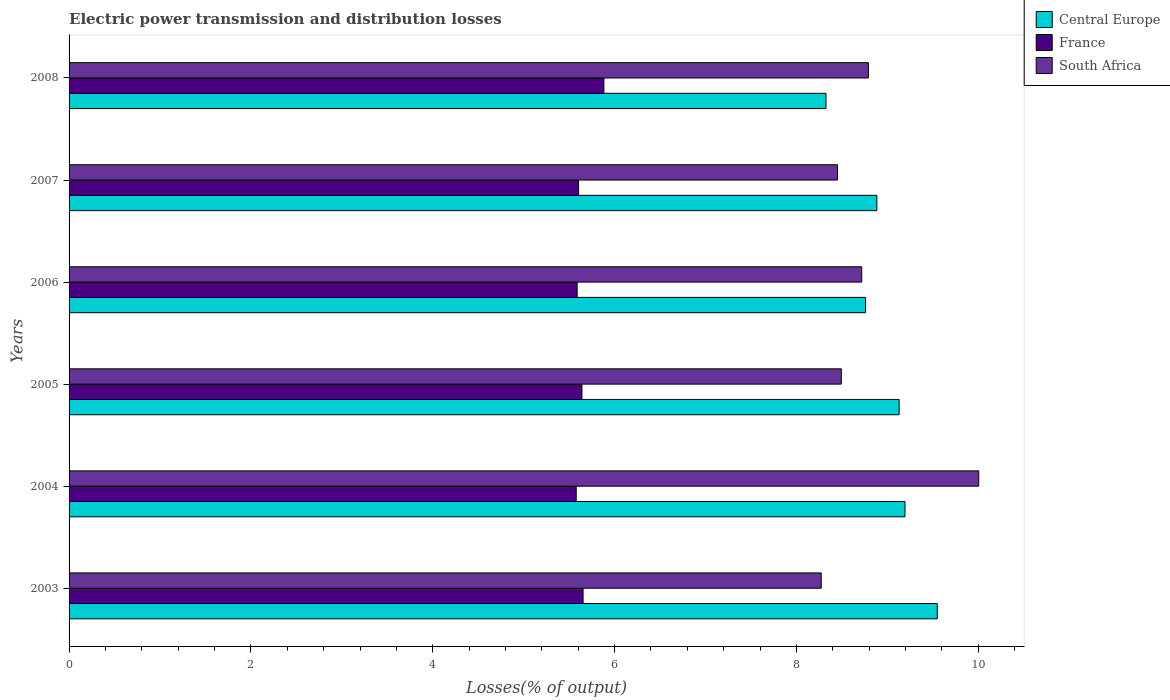Are the number of bars on each tick of the Y-axis equal?
Ensure brevity in your answer.  Yes. How many bars are there on the 2nd tick from the top?
Your answer should be very brief. 3. In how many cases, is the number of bars for a given year not equal to the number of legend labels?
Give a very brief answer. 0. What is the electric power transmission and distribution losses in Central Europe in 2004?
Keep it short and to the point. 9.19. Across all years, what is the maximum electric power transmission and distribution losses in France?
Provide a short and direct response. 5.88. Across all years, what is the minimum electric power transmission and distribution losses in France?
Your response must be concise. 5.58. In which year was the electric power transmission and distribution losses in Central Europe minimum?
Your answer should be very brief. 2008. What is the total electric power transmission and distribution losses in France in the graph?
Your answer should be compact. 33.95. What is the difference between the electric power transmission and distribution losses in France in 2007 and that in 2008?
Make the answer very short. -0.28. What is the difference between the electric power transmission and distribution losses in Central Europe in 2006 and the electric power transmission and distribution losses in France in 2007?
Give a very brief answer. 3.16. What is the average electric power transmission and distribution losses in France per year?
Offer a very short reply. 5.66. In the year 2004, what is the difference between the electric power transmission and distribution losses in France and electric power transmission and distribution losses in Central Europe?
Your response must be concise. -3.62. In how many years, is the electric power transmission and distribution losses in Central Europe greater than 7.2 %?
Provide a short and direct response. 6. What is the ratio of the electric power transmission and distribution losses in South Africa in 2004 to that in 2006?
Make the answer very short. 1.15. Is the difference between the electric power transmission and distribution losses in France in 2003 and 2005 greater than the difference between the electric power transmission and distribution losses in Central Europe in 2003 and 2005?
Your answer should be compact. No. What is the difference between the highest and the second highest electric power transmission and distribution losses in France?
Ensure brevity in your answer.  0.23. What is the difference between the highest and the lowest electric power transmission and distribution losses in Central Europe?
Give a very brief answer. 1.22. In how many years, is the electric power transmission and distribution losses in Central Europe greater than the average electric power transmission and distribution losses in Central Europe taken over all years?
Make the answer very short. 3. What does the 3rd bar from the top in 2004 represents?
Ensure brevity in your answer.  Central Europe. What does the 2nd bar from the bottom in 2007 represents?
Your response must be concise. France. Is it the case that in every year, the sum of the electric power transmission and distribution losses in France and electric power transmission and distribution losses in Central Europe is greater than the electric power transmission and distribution losses in South Africa?
Keep it short and to the point. Yes. How many bars are there?
Your answer should be compact. 18. Are all the bars in the graph horizontal?
Make the answer very short. Yes. How many years are there in the graph?
Ensure brevity in your answer.  6. What is the difference between two consecutive major ticks on the X-axis?
Give a very brief answer. 2. How are the legend labels stacked?
Your answer should be compact. Vertical. What is the title of the graph?
Provide a short and direct response. Electric power transmission and distribution losses. What is the label or title of the X-axis?
Provide a succinct answer. Losses(% of output). What is the label or title of the Y-axis?
Your response must be concise. Years. What is the Losses(% of output) in Central Europe in 2003?
Provide a succinct answer. 9.55. What is the Losses(% of output) in France in 2003?
Provide a short and direct response. 5.65. What is the Losses(% of output) in South Africa in 2003?
Offer a very short reply. 8.27. What is the Losses(% of output) in Central Europe in 2004?
Provide a succinct answer. 9.19. What is the Losses(% of output) of France in 2004?
Your answer should be very brief. 5.58. What is the Losses(% of output) of South Africa in 2004?
Give a very brief answer. 10. What is the Losses(% of output) in Central Europe in 2005?
Ensure brevity in your answer.  9.13. What is the Losses(% of output) of France in 2005?
Keep it short and to the point. 5.64. What is the Losses(% of output) in South Africa in 2005?
Ensure brevity in your answer.  8.49. What is the Losses(% of output) of Central Europe in 2006?
Make the answer very short. 8.76. What is the Losses(% of output) of France in 2006?
Keep it short and to the point. 5.59. What is the Losses(% of output) of South Africa in 2006?
Keep it short and to the point. 8.72. What is the Losses(% of output) of Central Europe in 2007?
Your response must be concise. 8.88. What is the Losses(% of output) in France in 2007?
Your answer should be very brief. 5.6. What is the Losses(% of output) of South Africa in 2007?
Provide a short and direct response. 8.45. What is the Losses(% of output) in Central Europe in 2008?
Make the answer very short. 8.33. What is the Losses(% of output) of France in 2008?
Give a very brief answer. 5.88. What is the Losses(% of output) of South Africa in 2008?
Your answer should be compact. 8.79. Across all years, what is the maximum Losses(% of output) in Central Europe?
Provide a short and direct response. 9.55. Across all years, what is the maximum Losses(% of output) in France?
Offer a very short reply. 5.88. Across all years, what is the maximum Losses(% of output) of South Africa?
Give a very brief answer. 10. Across all years, what is the minimum Losses(% of output) in Central Europe?
Your answer should be compact. 8.33. Across all years, what is the minimum Losses(% of output) of France?
Offer a terse response. 5.58. Across all years, what is the minimum Losses(% of output) in South Africa?
Provide a short and direct response. 8.27. What is the total Losses(% of output) in Central Europe in the graph?
Keep it short and to the point. 53.84. What is the total Losses(% of output) of France in the graph?
Provide a short and direct response. 33.95. What is the total Losses(% of output) in South Africa in the graph?
Offer a very short reply. 52.73. What is the difference between the Losses(% of output) in Central Europe in 2003 and that in 2004?
Keep it short and to the point. 0.36. What is the difference between the Losses(% of output) in France in 2003 and that in 2004?
Your answer should be compact. 0.08. What is the difference between the Losses(% of output) of South Africa in 2003 and that in 2004?
Offer a very short reply. -1.73. What is the difference between the Losses(% of output) in Central Europe in 2003 and that in 2005?
Provide a succinct answer. 0.42. What is the difference between the Losses(% of output) in France in 2003 and that in 2005?
Provide a succinct answer. 0.01. What is the difference between the Losses(% of output) in South Africa in 2003 and that in 2005?
Ensure brevity in your answer.  -0.22. What is the difference between the Losses(% of output) of Central Europe in 2003 and that in 2006?
Your answer should be compact. 0.79. What is the difference between the Losses(% of output) of France in 2003 and that in 2006?
Your answer should be very brief. 0.07. What is the difference between the Losses(% of output) of South Africa in 2003 and that in 2006?
Ensure brevity in your answer.  -0.45. What is the difference between the Losses(% of output) of Central Europe in 2003 and that in 2007?
Provide a succinct answer. 0.66. What is the difference between the Losses(% of output) of France in 2003 and that in 2007?
Provide a succinct answer. 0.05. What is the difference between the Losses(% of output) of South Africa in 2003 and that in 2007?
Provide a short and direct response. -0.18. What is the difference between the Losses(% of output) in Central Europe in 2003 and that in 2008?
Ensure brevity in your answer.  1.22. What is the difference between the Losses(% of output) of France in 2003 and that in 2008?
Offer a terse response. -0.23. What is the difference between the Losses(% of output) in South Africa in 2003 and that in 2008?
Offer a very short reply. -0.52. What is the difference between the Losses(% of output) of Central Europe in 2004 and that in 2005?
Keep it short and to the point. 0.06. What is the difference between the Losses(% of output) in France in 2004 and that in 2005?
Ensure brevity in your answer.  -0.06. What is the difference between the Losses(% of output) in South Africa in 2004 and that in 2005?
Offer a very short reply. 1.51. What is the difference between the Losses(% of output) of Central Europe in 2004 and that in 2006?
Keep it short and to the point. 0.43. What is the difference between the Losses(% of output) in France in 2004 and that in 2006?
Give a very brief answer. -0.01. What is the difference between the Losses(% of output) of South Africa in 2004 and that in 2006?
Your answer should be very brief. 1.29. What is the difference between the Losses(% of output) in Central Europe in 2004 and that in 2007?
Provide a short and direct response. 0.31. What is the difference between the Losses(% of output) in France in 2004 and that in 2007?
Keep it short and to the point. -0.03. What is the difference between the Losses(% of output) of South Africa in 2004 and that in 2007?
Offer a terse response. 1.55. What is the difference between the Losses(% of output) of Central Europe in 2004 and that in 2008?
Give a very brief answer. 0.87. What is the difference between the Losses(% of output) in France in 2004 and that in 2008?
Ensure brevity in your answer.  -0.3. What is the difference between the Losses(% of output) of South Africa in 2004 and that in 2008?
Ensure brevity in your answer.  1.21. What is the difference between the Losses(% of output) in Central Europe in 2005 and that in 2006?
Offer a terse response. 0.37. What is the difference between the Losses(% of output) of France in 2005 and that in 2006?
Offer a terse response. 0.05. What is the difference between the Losses(% of output) in South Africa in 2005 and that in 2006?
Your answer should be very brief. -0.22. What is the difference between the Losses(% of output) of Central Europe in 2005 and that in 2007?
Provide a succinct answer. 0.24. What is the difference between the Losses(% of output) of France in 2005 and that in 2007?
Provide a succinct answer. 0.04. What is the difference between the Losses(% of output) of South Africa in 2005 and that in 2007?
Provide a short and direct response. 0.04. What is the difference between the Losses(% of output) of Central Europe in 2005 and that in 2008?
Your answer should be compact. 0.8. What is the difference between the Losses(% of output) in France in 2005 and that in 2008?
Your answer should be very brief. -0.24. What is the difference between the Losses(% of output) in South Africa in 2005 and that in 2008?
Provide a short and direct response. -0.3. What is the difference between the Losses(% of output) of Central Europe in 2006 and that in 2007?
Your answer should be very brief. -0.12. What is the difference between the Losses(% of output) of France in 2006 and that in 2007?
Give a very brief answer. -0.02. What is the difference between the Losses(% of output) of South Africa in 2006 and that in 2007?
Make the answer very short. 0.27. What is the difference between the Losses(% of output) in Central Europe in 2006 and that in 2008?
Offer a very short reply. 0.43. What is the difference between the Losses(% of output) in France in 2006 and that in 2008?
Offer a terse response. -0.29. What is the difference between the Losses(% of output) of South Africa in 2006 and that in 2008?
Offer a terse response. -0.07. What is the difference between the Losses(% of output) of Central Europe in 2007 and that in 2008?
Provide a short and direct response. 0.56. What is the difference between the Losses(% of output) in France in 2007 and that in 2008?
Provide a short and direct response. -0.28. What is the difference between the Losses(% of output) in South Africa in 2007 and that in 2008?
Your answer should be very brief. -0.34. What is the difference between the Losses(% of output) in Central Europe in 2003 and the Losses(% of output) in France in 2004?
Offer a very short reply. 3.97. What is the difference between the Losses(% of output) in Central Europe in 2003 and the Losses(% of output) in South Africa in 2004?
Keep it short and to the point. -0.46. What is the difference between the Losses(% of output) of France in 2003 and the Losses(% of output) of South Africa in 2004?
Your response must be concise. -4.35. What is the difference between the Losses(% of output) in Central Europe in 2003 and the Losses(% of output) in France in 2005?
Keep it short and to the point. 3.91. What is the difference between the Losses(% of output) of Central Europe in 2003 and the Losses(% of output) of South Africa in 2005?
Offer a terse response. 1.06. What is the difference between the Losses(% of output) of France in 2003 and the Losses(% of output) of South Africa in 2005?
Provide a short and direct response. -2.84. What is the difference between the Losses(% of output) in Central Europe in 2003 and the Losses(% of output) in France in 2006?
Provide a short and direct response. 3.96. What is the difference between the Losses(% of output) in Central Europe in 2003 and the Losses(% of output) in South Africa in 2006?
Ensure brevity in your answer.  0.83. What is the difference between the Losses(% of output) in France in 2003 and the Losses(% of output) in South Africa in 2006?
Make the answer very short. -3.06. What is the difference between the Losses(% of output) in Central Europe in 2003 and the Losses(% of output) in France in 2007?
Your answer should be very brief. 3.95. What is the difference between the Losses(% of output) in Central Europe in 2003 and the Losses(% of output) in South Africa in 2007?
Your response must be concise. 1.1. What is the difference between the Losses(% of output) in France in 2003 and the Losses(% of output) in South Africa in 2007?
Your answer should be very brief. -2.8. What is the difference between the Losses(% of output) of Central Europe in 2003 and the Losses(% of output) of France in 2008?
Your response must be concise. 3.67. What is the difference between the Losses(% of output) in Central Europe in 2003 and the Losses(% of output) in South Africa in 2008?
Offer a very short reply. 0.76. What is the difference between the Losses(% of output) of France in 2003 and the Losses(% of output) of South Africa in 2008?
Give a very brief answer. -3.14. What is the difference between the Losses(% of output) of Central Europe in 2004 and the Losses(% of output) of France in 2005?
Your answer should be compact. 3.55. What is the difference between the Losses(% of output) in Central Europe in 2004 and the Losses(% of output) in South Africa in 2005?
Offer a very short reply. 0.7. What is the difference between the Losses(% of output) of France in 2004 and the Losses(% of output) of South Africa in 2005?
Offer a very short reply. -2.92. What is the difference between the Losses(% of output) in Central Europe in 2004 and the Losses(% of output) in France in 2006?
Your answer should be compact. 3.61. What is the difference between the Losses(% of output) of Central Europe in 2004 and the Losses(% of output) of South Africa in 2006?
Keep it short and to the point. 0.48. What is the difference between the Losses(% of output) of France in 2004 and the Losses(% of output) of South Africa in 2006?
Your answer should be very brief. -3.14. What is the difference between the Losses(% of output) in Central Europe in 2004 and the Losses(% of output) in France in 2007?
Give a very brief answer. 3.59. What is the difference between the Losses(% of output) of Central Europe in 2004 and the Losses(% of output) of South Africa in 2007?
Your answer should be very brief. 0.74. What is the difference between the Losses(% of output) of France in 2004 and the Losses(% of output) of South Africa in 2007?
Offer a terse response. -2.87. What is the difference between the Losses(% of output) of Central Europe in 2004 and the Losses(% of output) of France in 2008?
Your response must be concise. 3.31. What is the difference between the Losses(% of output) in Central Europe in 2004 and the Losses(% of output) in South Africa in 2008?
Give a very brief answer. 0.4. What is the difference between the Losses(% of output) of France in 2004 and the Losses(% of output) of South Africa in 2008?
Your answer should be compact. -3.21. What is the difference between the Losses(% of output) of Central Europe in 2005 and the Losses(% of output) of France in 2006?
Your response must be concise. 3.54. What is the difference between the Losses(% of output) of Central Europe in 2005 and the Losses(% of output) of South Africa in 2006?
Provide a short and direct response. 0.41. What is the difference between the Losses(% of output) of France in 2005 and the Losses(% of output) of South Africa in 2006?
Make the answer very short. -3.08. What is the difference between the Losses(% of output) in Central Europe in 2005 and the Losses(% of output) in France in 2007?
Provide a short and direct response. 3.53. What is the difference between the Losses(% of output) of Central Europe in 2005 and the Losses(% of output) of South Africa in 2007?
Make the answer very short. 0.68. What is the difference between the Losses(% of output) in France in 2005 and the Losses(% of output) in South Africa in 2007?
Provide a succinct answer. -2.81. What is the difference between the Losses(% of output) in Central Europe in 2005 and the Losses(% of output) in France in 2008?
Your answer should be compact. 3.25. What is the difference between the Losses(% of output) of Central Europe in 2005 and the Losses(% of output) of South Africa in 2008?
Make the answer very short. 0.34. What is the difference between the Losses(% of output) of France in 2005 and the Losses(% of output) of South Africa in 2008?
Your answer should be compact. -3.15. What is the difference between the Losses(% of output) of Central Europe in 2006 and the Losses(% of output) of France in 2007?
Your answer should be very brief. 3.16. What is the difference between the Losses(% of output) in Central Europe in 2006 and the Losses(% of output) in South Africa in 2007?
Provide a succinct answer. 0.31. What is the difference between the Losses(% of output) in France in 2006 and the Losses(% of output) in South Africa in 2007?
Offer a very short reply. -2.86. What is the difference between the Losses(% of output) of Central Europe in 2006 and the Losses(% of output) of France in 2008?
Make the answer very short. 2.88. What is the difference between the Losses(% of output) of Central Europe in 2006 and the Losses(% of output) of South Africa in 2008?
Offer a terse response. -0.03. What is the difference between the Losses(% of output) in France in 2006 and the Losses(% of output) in South Africa in 2008?
Keep it short and to the point. -3.2. What is the difference between the Losses(% of output) in Central Europe in 2007 and the Losses(% of output) in France in 2008?
Keep it short and to the point. 3. What is the difference between the Losses(% of output) of Central Europe in 2007 and the Losses(% of output) of South Africa in 2008?
Your answer should be very brief. 0.09. What is the difference between the Losses(% of output) in France in 2007 and the Losses(% of output) in South Africa in 2008?
Ensure brevity in your answer.  -3.19. What is the average Losses(% of output) in Central Europe per year?
Your answer should be compact. 8.97. What is the average Losses(% of output) in France per year?
Make the answer very short. 5.66. What is the average Losses(% of output) of South Africa per year?
Make the answer very short. 8.79. In the year 2003, what is the difference between the Losses(% of output) of Central Europe and Losses(% of output) of France?
Keep it short and to the point. 3.9. In the year 2003, what is the difference between the Losses(% of output) of Central Europe and Losses(% of output) of South Africa?
Offer a very short reply. 1.28. In the year 2003, what is the difference between the Losses(% of output) in France and Losses(% of output) in South Africa?
Your response must be concise. -2.62. In the year 2004, what is the difference between the Losses(% of output) of Central Europe and Losses(% of output) of France?
Your answer should be very brief. 3.62. In the year 2004, what is the difference between the Losses(% of output) in Central Europe and Losses(% of output) in South Africa?
Provide a succinct answer. -0.81. In the year 2004, what is the difference between the Losses(% of output) in France and Losses(% of output) in South Africa?
Provide a short and direct response. -4.43. In the year 2005, what is the difference between the Losses(% of output) of Central Europe and Losses(% of output) of France?
Offer a very short reply. 3.49. In the year 2005, what is the difference between the Losses(% of output) of Central Europe and Losses(% of output) of South Africa?
Keep it short and to the point. 0.64. In the year 2005, what is the difference between the Losses(% of output) of France and Losses(% of output) of South Africa?
Offer a very short reply. -2.85. In the year 2006, what is the difference between the Losses(% of output) of Central Europe and Losses(% of output) of France?
Your answer should be very brief. 3.17. In the year 2006, what is the difference between the Losses(% of output) in Central Europe and Losses(% of output) in South Africa?
Your response must be concise. 0.04. In the year 2006, what is the difference between the Losses(% of output) of France and Losses(% of output) of South Africa?
Your answer should be very brief. -3.13. In the year 2007, what is the difference between the Losses(% of output) of Central Europe and Losses(% of output) of France?
Provide a short and direct response. 3.28. In the year 2007, what is the difference between the Losses(% of output) in Central Europe and Losses(% of output) in South Africa?
Your answer should be very brief. 0.43. In the year 2007, what is the difference between the Losses(% of output) of France and Losses(% of output) of South Africa?
Your answer should be very brief. -2.85. In the year 2008, what is the difference between the Losses(% of output) in Central Europe and Losses(% of output) in France?
Ensure brevity in your answer.  2.44. In the year 2008, what is the difference between the Losses(% of output) in Central Europe and Losses(% of output) in South Africa?
Your answer should be very brief. -0.47. In the year 2008, what is the difference between the Losses(% of output) in France and Losses(% of output) in South Africa?
Your response must be concise. -2.91. What is the ratio of the Losses(% of output) in Central Europe in 2003 to that in 2004?
Provide a succinct answer. 1.04. What is the ratio of the Losses(% of output) in France in 2003 to that in 2004?
Provide a short and direct response. 1.01. What is the ratio of the Losses(% of output) in South Africa in 2003 to that in 2004?
Ensure brevity in your answer.  0.83. What is the ratio of the Losses(% of output) of Central Europe in 2003 to that in 2005?
Keep it short and to the point. 1.05. What is the ratio of the Losses(% of output) of South Africa in 2003 to that in 2005?
Provide a short and direct response. 0.97. What is the ratio of the Losses(% of output) in Central Europe in 2003 to that in 2006?
Provide a succinct answer. 1.09. What is the ratio of the Losses(% of output) of France in 2003 to that in 2006?
Your answer should be very brief. 1.01. What is the ratio of the Losses(% of output) of South Africa in 2003 to that in 2006?
Provide a succinct answer. 0.95. What is the ratio of the Losses(% of output) in Central Europe in 2003 to that in 2007?
Your answer should be very brief. 1.07. What is the ratio of the Losses(% of output) of France in 2003 to that in 2007?
Give a very brief answer. 1.01. What is the ratio of the Losses(% of output) in South Africa in 2003 to that in 2007?
Your response must be concise. 0.98. What is the ratio of the Losses(% of output) in Central Europe in 2003 to that in 2008?
Your answer should be compact. 1.15. What is the ratio of the Losses(% of output) in France in 2003 to that in 2008?
Give a very brief answer. 0.96. What is the ratio of the Losses(% of output) in South Africa in 2003 to that in 2008?
Provide a succinct answer. 0.94. What is the ratio of the Losses(% of output) of Central Europe in 2004 to that in 2005?
Provide a succinct answer. 1.01. What is the ratio of the Losses(% of output) in France in 2004 to that in 2005?
Your answer should be very brief. 0.99. What is the ratio of the Losses(% of output) in South Africa in 2004 to that in 2005?
Offer a very short reply. 1.18. What is the ratio of the Losses(% of output) of Central Europe in 2004 to that in 2006?
Ensure brevity in your answer.  1.05. What is the ratio of the Losses(% of output) of France in 2004 to that in 2006?
Offer a terse response. 1. What is the ratio of the Losses(% of output) in South Africa in 2004 to that in 2006?
Offer a terse response. 1.15. What is the ratio of the Losses(% of output) of Central Europe in 2004 to that in 2007?
Offer a terse response. 1.03. What is the ratio of the Losses(% of output) of France in 2004 to that in 2007?
Keep it short and to the point. 1. What is the ratio of the Losses(% of output) of South Africa in 2004 to that in 2007?
Ensure brevity in your answer.  1.18. What is the ratio of the Losses(% of output) in Central Europe in 2004 to that in 2008?
Offer a terse response. 1.1. What is the ratio of the Losses(% of output) in France in 2004 to that in 2008?
Offer a terse response. 0.95. What is the ratio of the Losses(% of output) of South Africa in 2004 to that in 2008?
Your answer should be very brief. 1.14. What is the ratio of the Losses(% of output) in Central Europe in 2005 to that in 2006?
Offer a very short reply. 1.04. What is the ratio of the Losses(% of output) in France in 2005 to that in 2006?
Provide a succinct answer. 1.01. What is the ratio of the Losses(% of output) of South Africa in 2005 to that in 2006?
Your answer should be compact. 0.97. What is the ratio of the Losses(% of output) of Central Europe in 2005 to that in 2007?
Keep it short and to the point. 1.03. What is the ratio of the Losses(% of output) in France in 2005 to that in 2007?
Provide a succinct answer. 1.01. What is the ratio of the Losses(% of output) of Central Europe in 2005 to that in 2008?
Your answer should be very brief. 1.1. What is the ratio of the Losses(% of output) in South Africa in 2005 to that in 2008?
Your answer should be compact. 0.97. What is the ratio of the Losses(% of output) in Central Europe in 2006 to that in 2007?
Provide a short and direct response. 0.99. What is the ratio of the Losses(% of output) in France in 2006 to that in 2007?
Provide a succinct answer. 1. What is the ratio of the Losses(% of output) of South Africa in 2006 to that in 2007?
Give a very brief answer. 1.03. What is the ratio of the Losses(% of output) in Central Europe in 2006 to that in 2008?
Your answer should be very brief. 1.05. What is the ratio of the Losses(% of output) of France in 2006 to that in 2008?
Provide a succinct answer. 0.95. What is the ratio of the Losses(% of output) of Central Europe in 2007 to that in 2008?
Keep it short and to the point. 1.07. What is the ratio of the Losses(% of output) in France in 2007 to that in 2008?
Your response must be concise. 0.95. What is the ratio of the Losses(% of output) in South Africa in 2007 to that in 2008?
Keep it short and to the point. 0.96. What is the difference between the highest and the second highest Losses(% of output) in Central Europe?
Provide a short and direct response. 0.36. What is the difference between the highest and the second highest Losses(% of output) in France?
Provide a succinct answer. 0.23. What is the difference between the highest and the second highest Losses(% of output) in South Africa?
Keep it short and to the point. 1.21. What is the difference between the highest and the lowest Losses(% of output) of Central Europe?
Keep it short and to the point. 1.22. What is the difference between the highest and the lowest Losses(% of output) in France?
Provide a succinct answer. 0.3. What is the difference between the highest and the lowest Losses(% of output) of South Africa?
Ensure brevity in your answer.  1.73. 